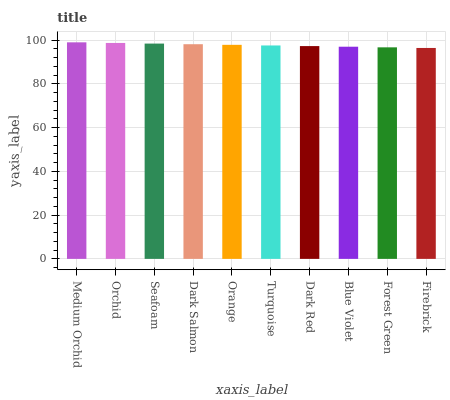Is Firebrick the minimum?
Answer yes or no. Yes. Is Medium Orchid the maximum?
Answer yes or no. Yes. Is Orchid the minimum?
Answer yes or no. No. Is Orchid the maximum?
Answer yes or no. No. Is Medium Orchid greater than Orchid?
Answer yes or no. Yes. Is Orchid less than Medium Orchid?
Answer yes or no. Yes. Is Orchid greater than Medium Orchid?
Answer yes or no. No. Is Medium Orchid less than Orchid?
Answer yes or no. No. Is Orange the high median?
Answer yes or no. Yes. Is Turquoise the low median?
Answer yes or no. Yes. Is Blue Violet the high median?
Answer yes or no. No. Is Dark Salmon the low median?
Answer yes or no. No. 